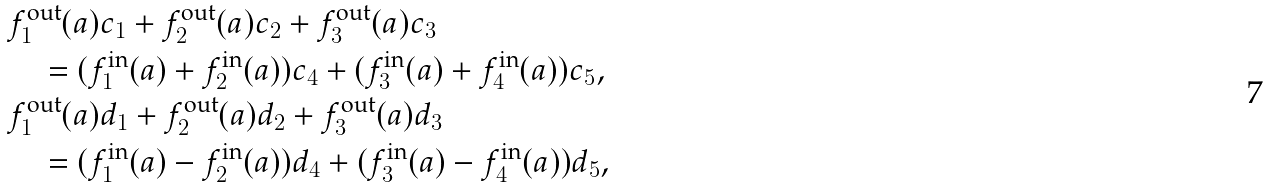Convert formula to latex. <formula><loc_0><loc_0><loc_500><loc_500>& f ^ { \text {out} } _ { 1 } ( a ) c _ { 1 } + f ^ { \text {out} } _ { 2 } ( a ) c _ { 2 } + f ^ { \text {out} } _ { 3 } ( a ) c _ { 3 } \\ & \quad = ( f ^ { \text {in} } _ { 1 } ( a ) + f ^ { \text {in} } _ { 2 } ( a ) ) c _ { 4 } + ( f ^ { \text {in} } _ { 3 } ( a ) + f ^ { \text {in} } _ { 4 } ( a ) ) c _ { 5 } , \\ & f ^ { \text {out} } _ { 1 } ( a ) d _ { 1 } + f ^ { \text {out} } _ { 2 } ( a ) d _ { 2 } + f ^ { \text {out} } _ { 3 } ( a ) d _ { 3 } \\ & \quad = ( f ^ { \text {in} } _ { 1 } ( a ) - f ^ { \text {in} } _ { 2 } ( a ) ) d _ { 4 } + ( f ^ { \text {in} } _ { 3 } ( a ) - f ^ { \text {in} } _ { 4 } ( a ) ) d _ { 5 } ,</formula> 